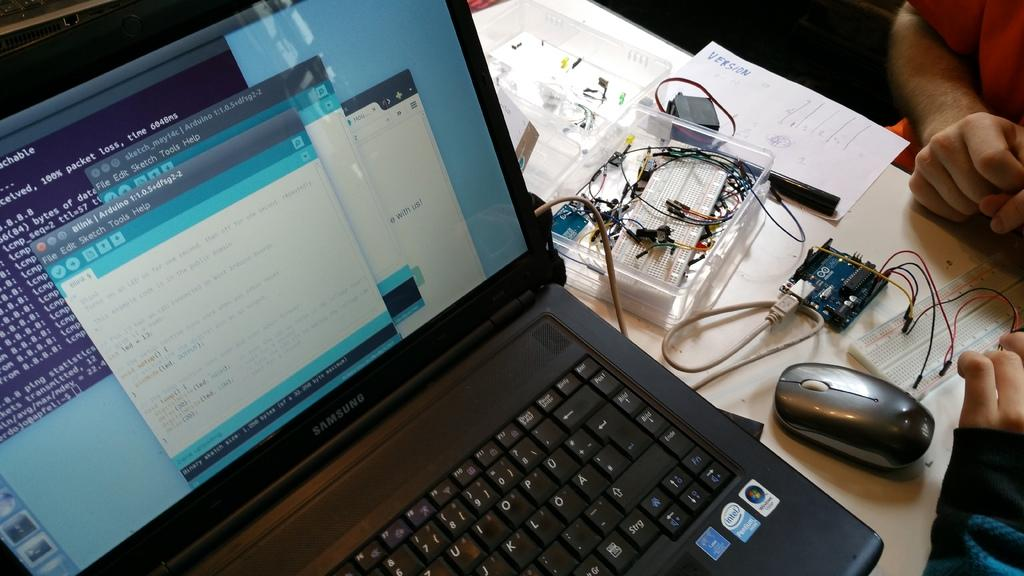Provide a one-sentence caption for the provided image. A samsung laptop displaying different forms and code sitting on a table. 